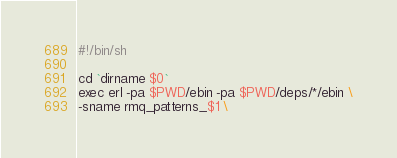<code> <loc_0><loc_0><loc_500><loc_500><_Bash_>#!/bin/sh

cd `dirname $0`
exec erl -pa $PWD/ebin -pa $PWD/deps/*/ebin \
-sname rmq_patterns_$1 \</code> 